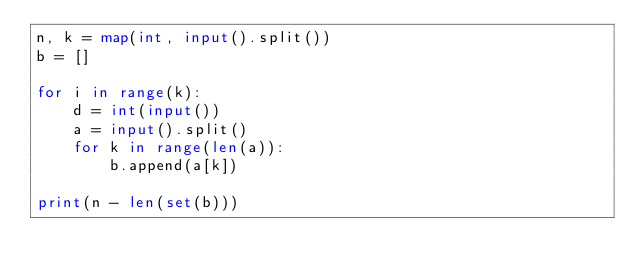<code> <loc_0><loc_0><loc_500><loc_500><_Python_>n, k = map(int, input().split())
b = []

for i in range(k):
    d = int(input())
    a = input().split()
    for k in range(len(a)):
        b.append(a[k])

print(n - len(set(b)))</code> 